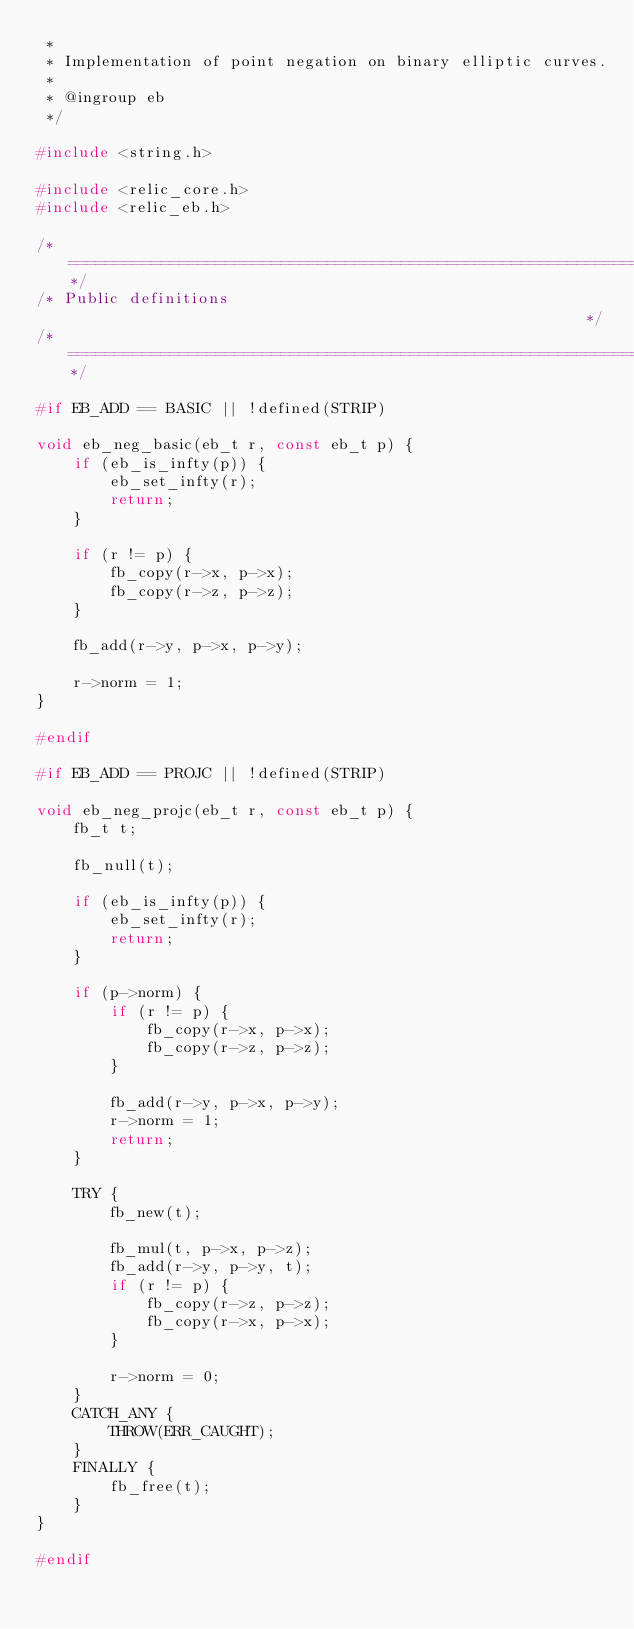<code> <loc_0><loc_0><loc_500><loc_500><_C_> *
 * Implementation of point negation on binary elliptic curves.
 *
 * @ingroup eb
 */

#include <string.h>

#include <relic_core.h>
#include <relic_eb.h>

/*============================================================================*/
/* Public definitions                                                         */
/*============================================================================*/

#if EB_ADD == BASIC || !defined(STRIP)

void eb_neg_basic(eb_t r, const eb_t p) {
	if (eb_is_infty(p)) {
		eb_set_infty(r);
		return;
	}

	if (r != p) {
		fb_copy(r->x, p->x);
		fb_copy(r->z, p->z);
	}

	fb_add(r->y, p->x, p->y);

	r->norm = 1;
}

#endif

#if EB_ADD == PROJC || !defined(STRIP)

void eb_neg_projc(eb_t r, const eb_t p) {
	fb_t t;

	fb_null(t);

	if (eb_is_infty(p)) {
		eb_set_infty(r);
		return;
	}

	if (p->norm) {
		if (r != p) {
			fb_copy(r->x, p->x);
			fb_copy(r->z, p->z);
		}

		fb_add(r->y, p->x, p->y);
		r->norm = 1;
		return;
	}

	TRY {
		fb_new(t);

		fb_mul(t, p->x, p->z);
		fb_add(r->y, p->y, t);
		if (r != p) {
			fb_copy(r->z, p->z);
			fb_copy(r->x, p->x);
		}

		r->norm = 0;
	}
	CATCH_ANY {
		THROW(ERR_CAUGHT);
	}
	FINALLY {
		fb_free(t);
	}
}

#endif
</code> 